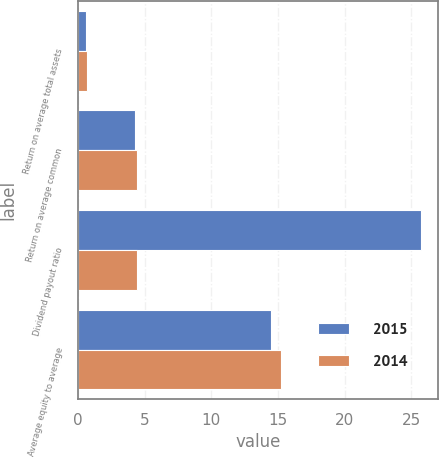Convert chart. <chart><loc_0><loc_0><loc_500><loc_500><stacked_bar_chart><ecel><fcel>Return on average total assets<fcel>Return on average common<fcel>Dividend payout ratio<fcel>Average equity to average<nl><fcel>2015<fcel>0.62<fcel>4.3<fcel>25.73<fcel>14.46<nl><fcel>2014<fcel>0.68<fcel>4.46<fcel>4.46<fcel>15.2<nl></chart> 